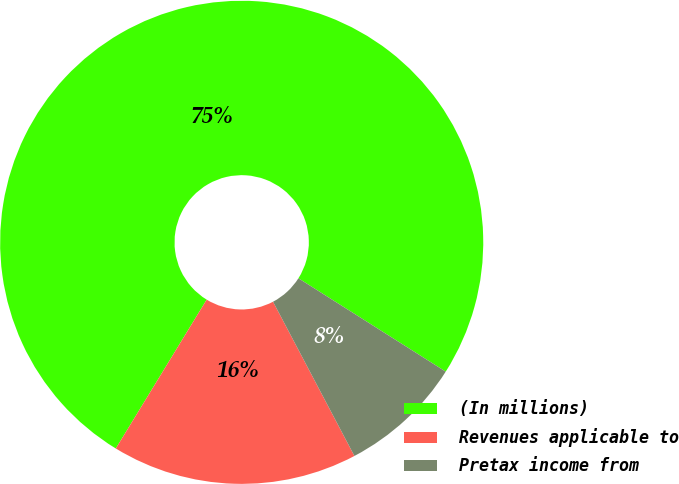Convert chart to OTSL. <chart><loc_0><loc_0><loc_500><loc_500><pie_chart><fcel>(In millions)<fcel>Revenues applicable to<fcel>Pretax income from<nl><fcel>75.26%<fcel>16.45%<fcel>8.28%<nl></chart> 